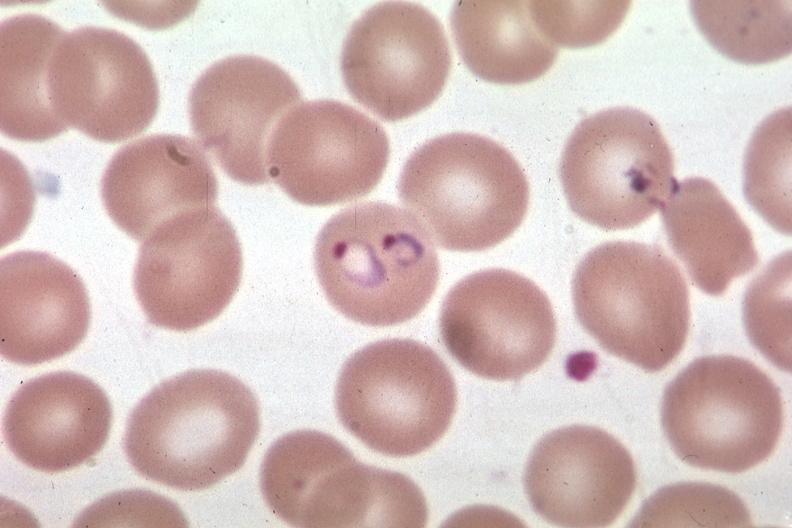what is present?
Answer the question using a single word or phrase. Malaria plasmodium vivax 